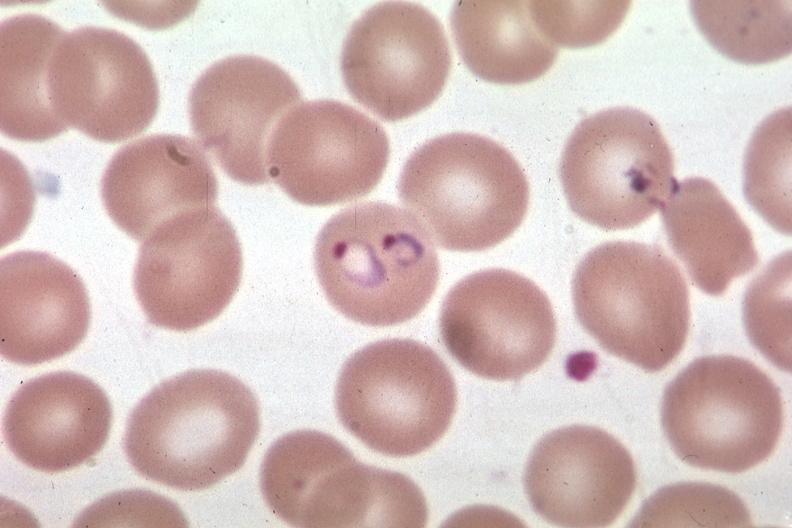what is present?
Answer the question using a single word or phrase. Malaria plasmodium vivax 